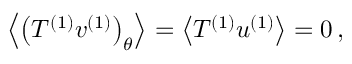Convert formula to latex. <formula><loc_0><loc_0><loc_500><loc_500>\begin{array} { r } { \left < \left ( T ^ { ( 1 ) } v ^ { ( 1 ) } \right ) _ { \theta } \right > = \left < T ^ { ( 1 ) } u ^ { ( 1 ) } \right > = 0 \, , } \end{array}</formula> 